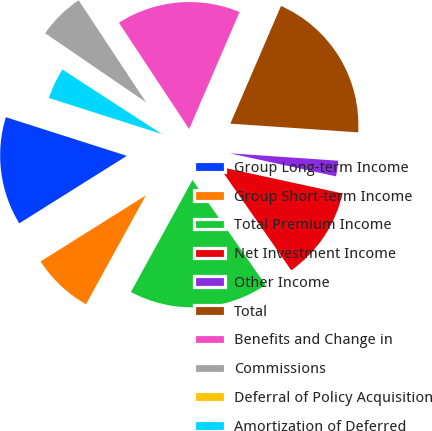<chart> <loc_0><loc_0><loc_500><loc_500><pie_chart><fcel>Group Long-term Income<fcel>Group Short-term Income<fcel>Total Premium Income<fcel>Net Investment Income<fcel>Other Income<fcel>Total<fcel>Benefits and Change in<fcel>Commissions<fcel>Deferral of Policy Acquisition<fcel>Amortization of Deferred<nl><fcel>13.84%<fcel>8.08%<fcel>17.68%<fcel>11.92%<fcel>2.32%<fcel>19.61%<fcel>15.76%<fcel>6.16%<fcel>0.39%<fcel>4.24%<nl></chart> 